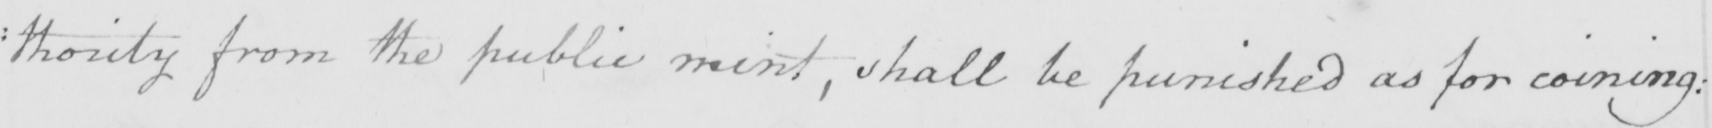Can you read and transcribe this handwriting? : thority from the public mint , shall be punished as for coining : 